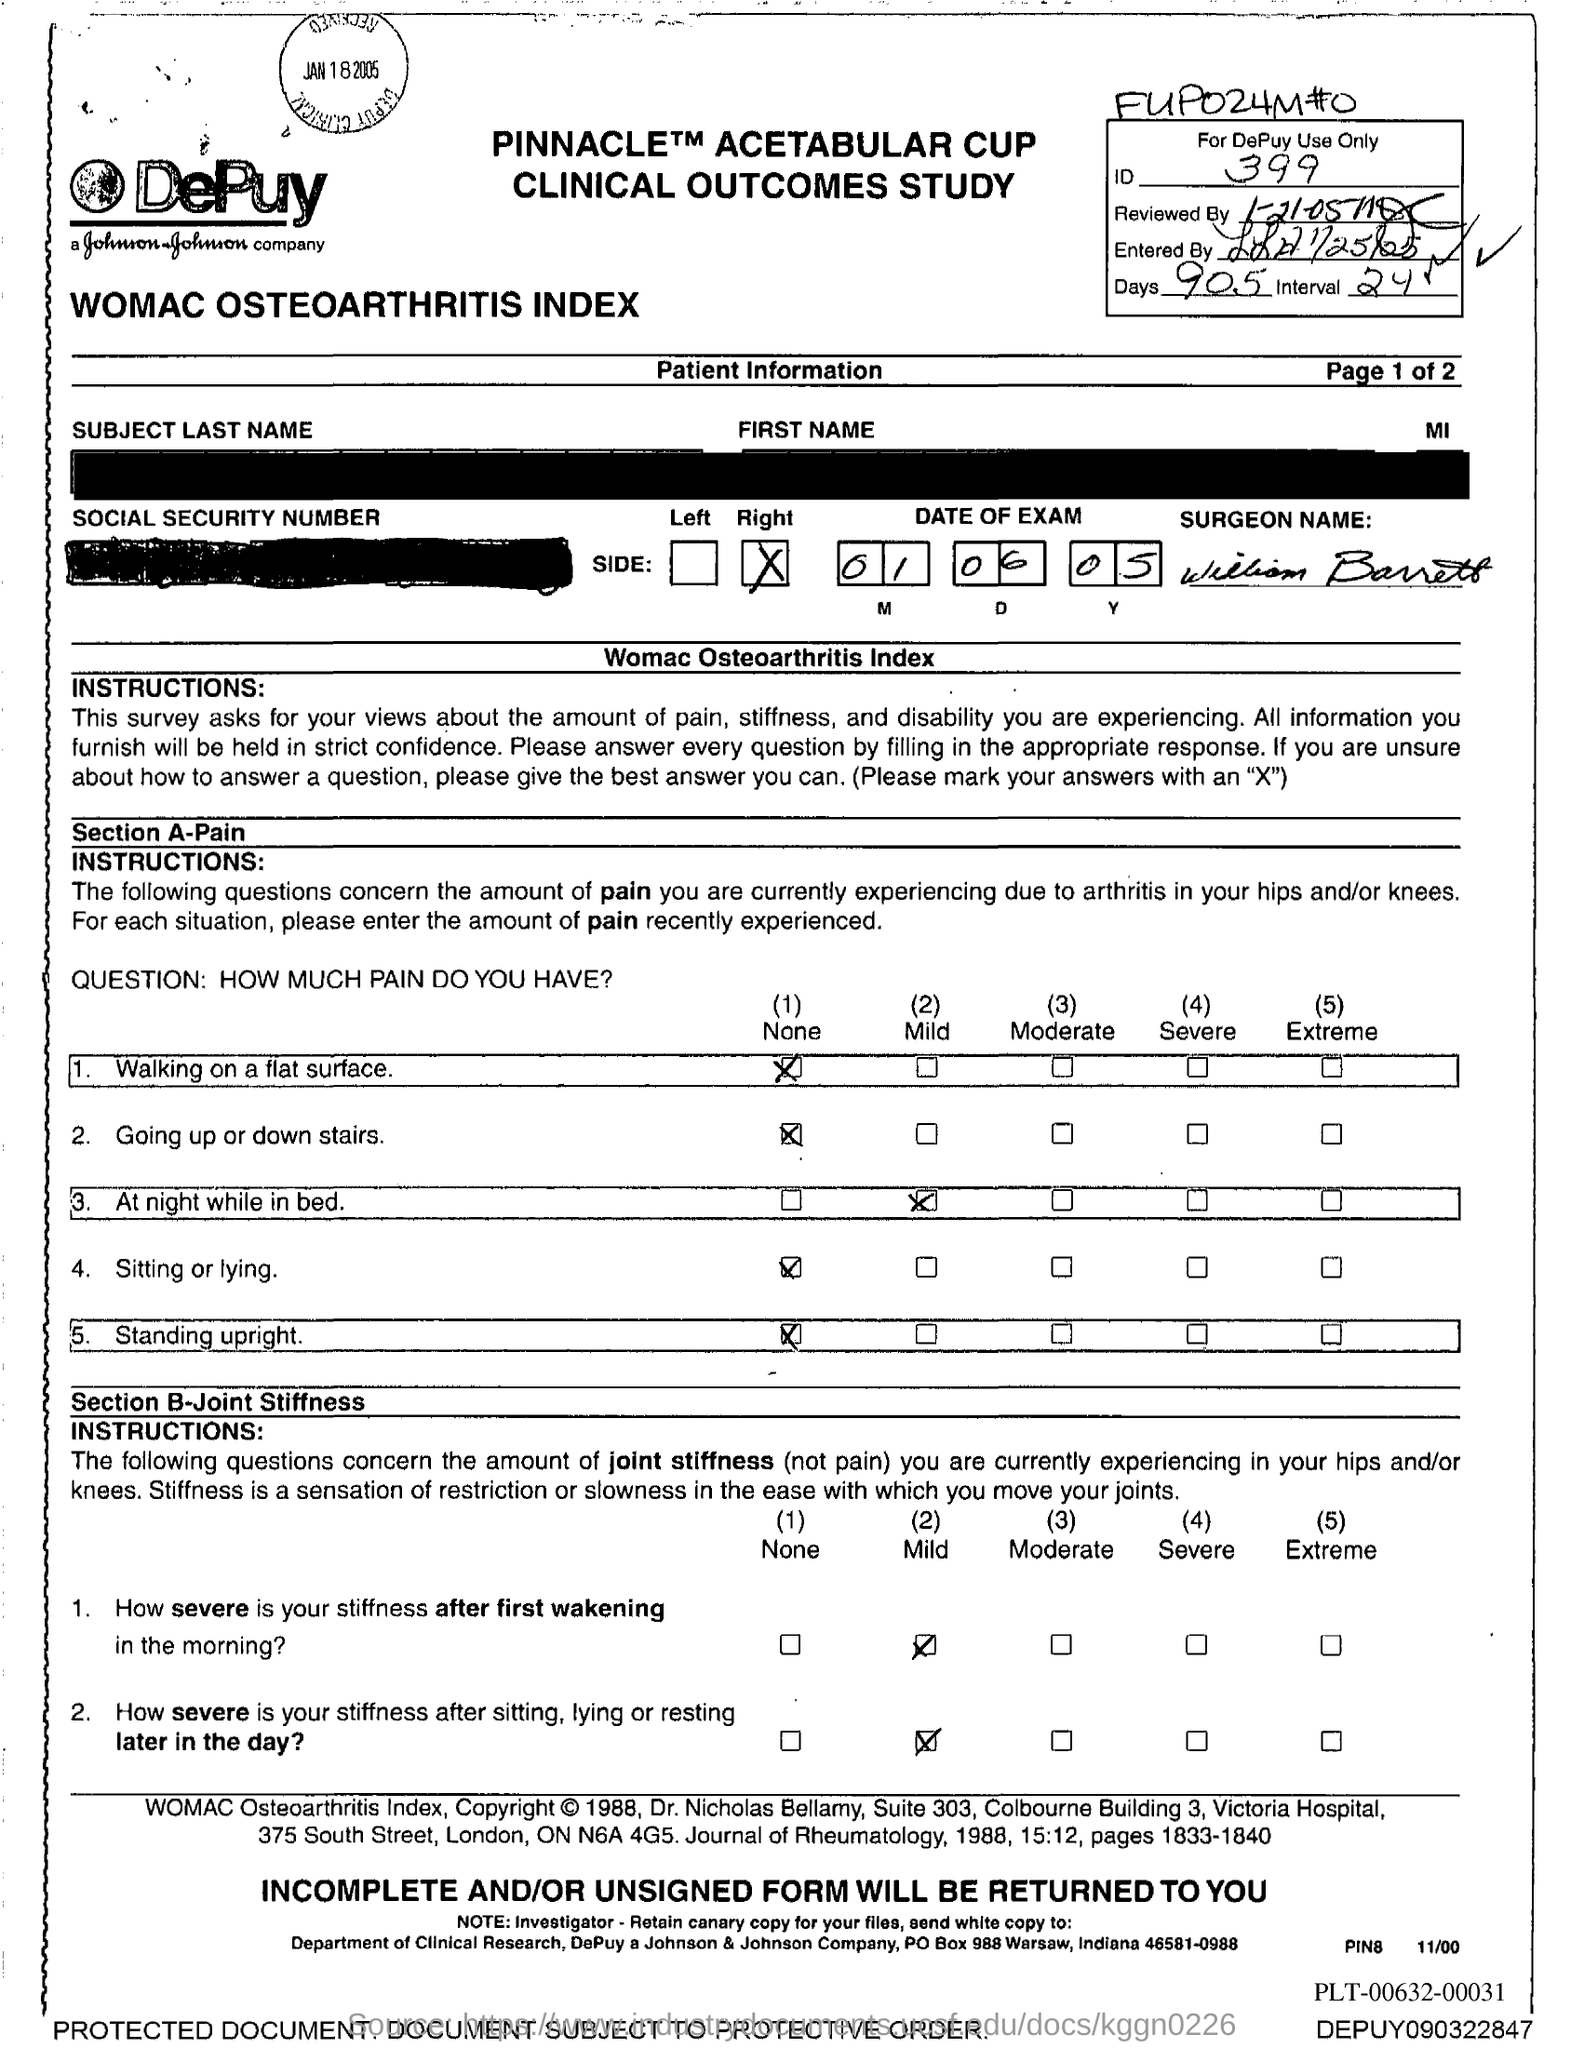What is the ID no. mentioned in the document?
Your response must be concise. 399. What is the no of days given in the document?
Offer a very short reply. 905. What is the date of exam mentioned in the document?
Offer a terse response. 01 06 05. 